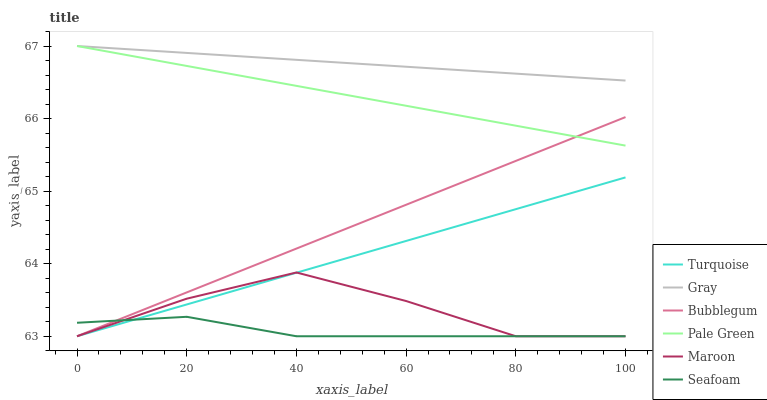Does Seafoam have the minimum area under the curve?
Answer yes or no. Yes. Does Gray have the maximum area under the curve?
Answer yes or no. Yes. Does Turquoise have the minimum area under the curve?
Answer yes or no. No. Does Turquoise have the maximum area under the curve?
Answer yes or no. No. Is Gray the smoothest?
Answer yes or no. Yes. Is Maroon the roughest?
Answer yes or no. Yes. Is Turquoise the smoothest?
Answer yes or no. No. Is Turquoise the roughest?
Answer yes or no. No. Does Turquoise have the lowest value?
Answer yes or no. Yes. Does Pale Green have the lowest value?
Answer yes or no. No. Does Pale Green have the highest value?
Answer yes or no. Yes. Does Turquoise have the highest value?
Answer yes or no. No. Is Bubblegum less than Gray?
Answer yes or no. Yes. Is Gray greater than Seafoam?
Answer yes or no. Yes. Does Pale Green intersect Bubblegum?
Answer yes or no. Yes. Is Pale Green less than Bubblegum?
Answer yes or no. No. Is Pale Green greater than Bubblegum?
Answer yes or no. No. Does Bubblegum intersect Gray?
Answer yes or no. No. 